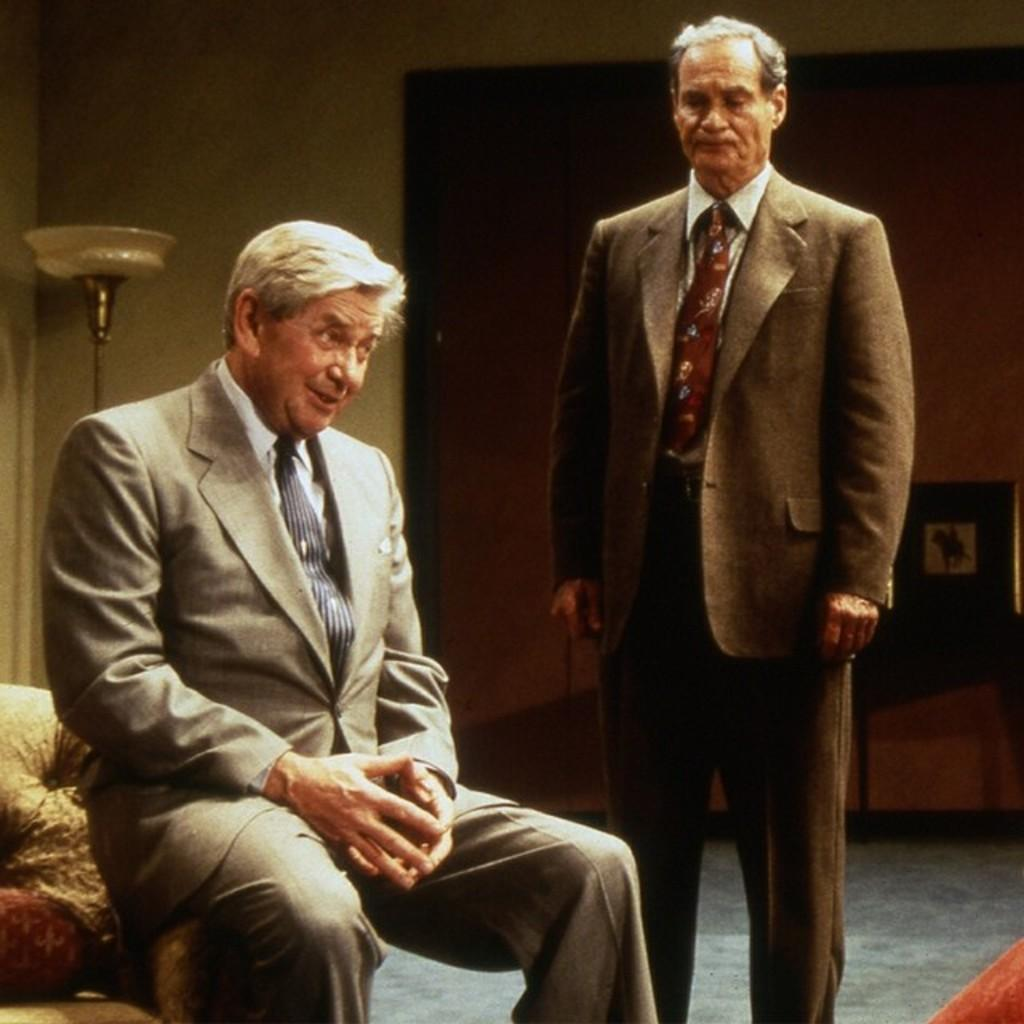How many people are in the image? There are two persons in the image. What is one person doing in the image? One person is sitting on a sofa. What can be seen behind the persons in the image? There is a wall visible in the image. What furniture is present in the image? There is a table in the image. What lighting fixture is present in the image? There is a lamp in the image. What is the writer and daughter are having a conversation in the image? There is no mention of a writer or daughter in the image, nor is there any indication of a conversation taking place. 